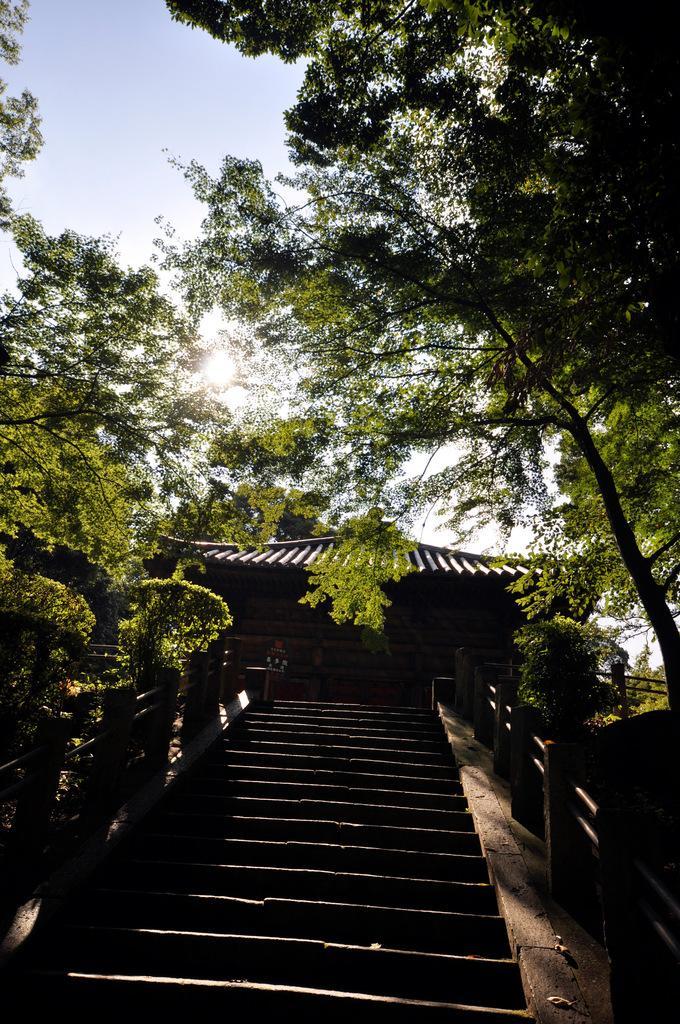Can you describe this image briefly? In this image we can see the steps, house, trees, sun and the sky in the background. 